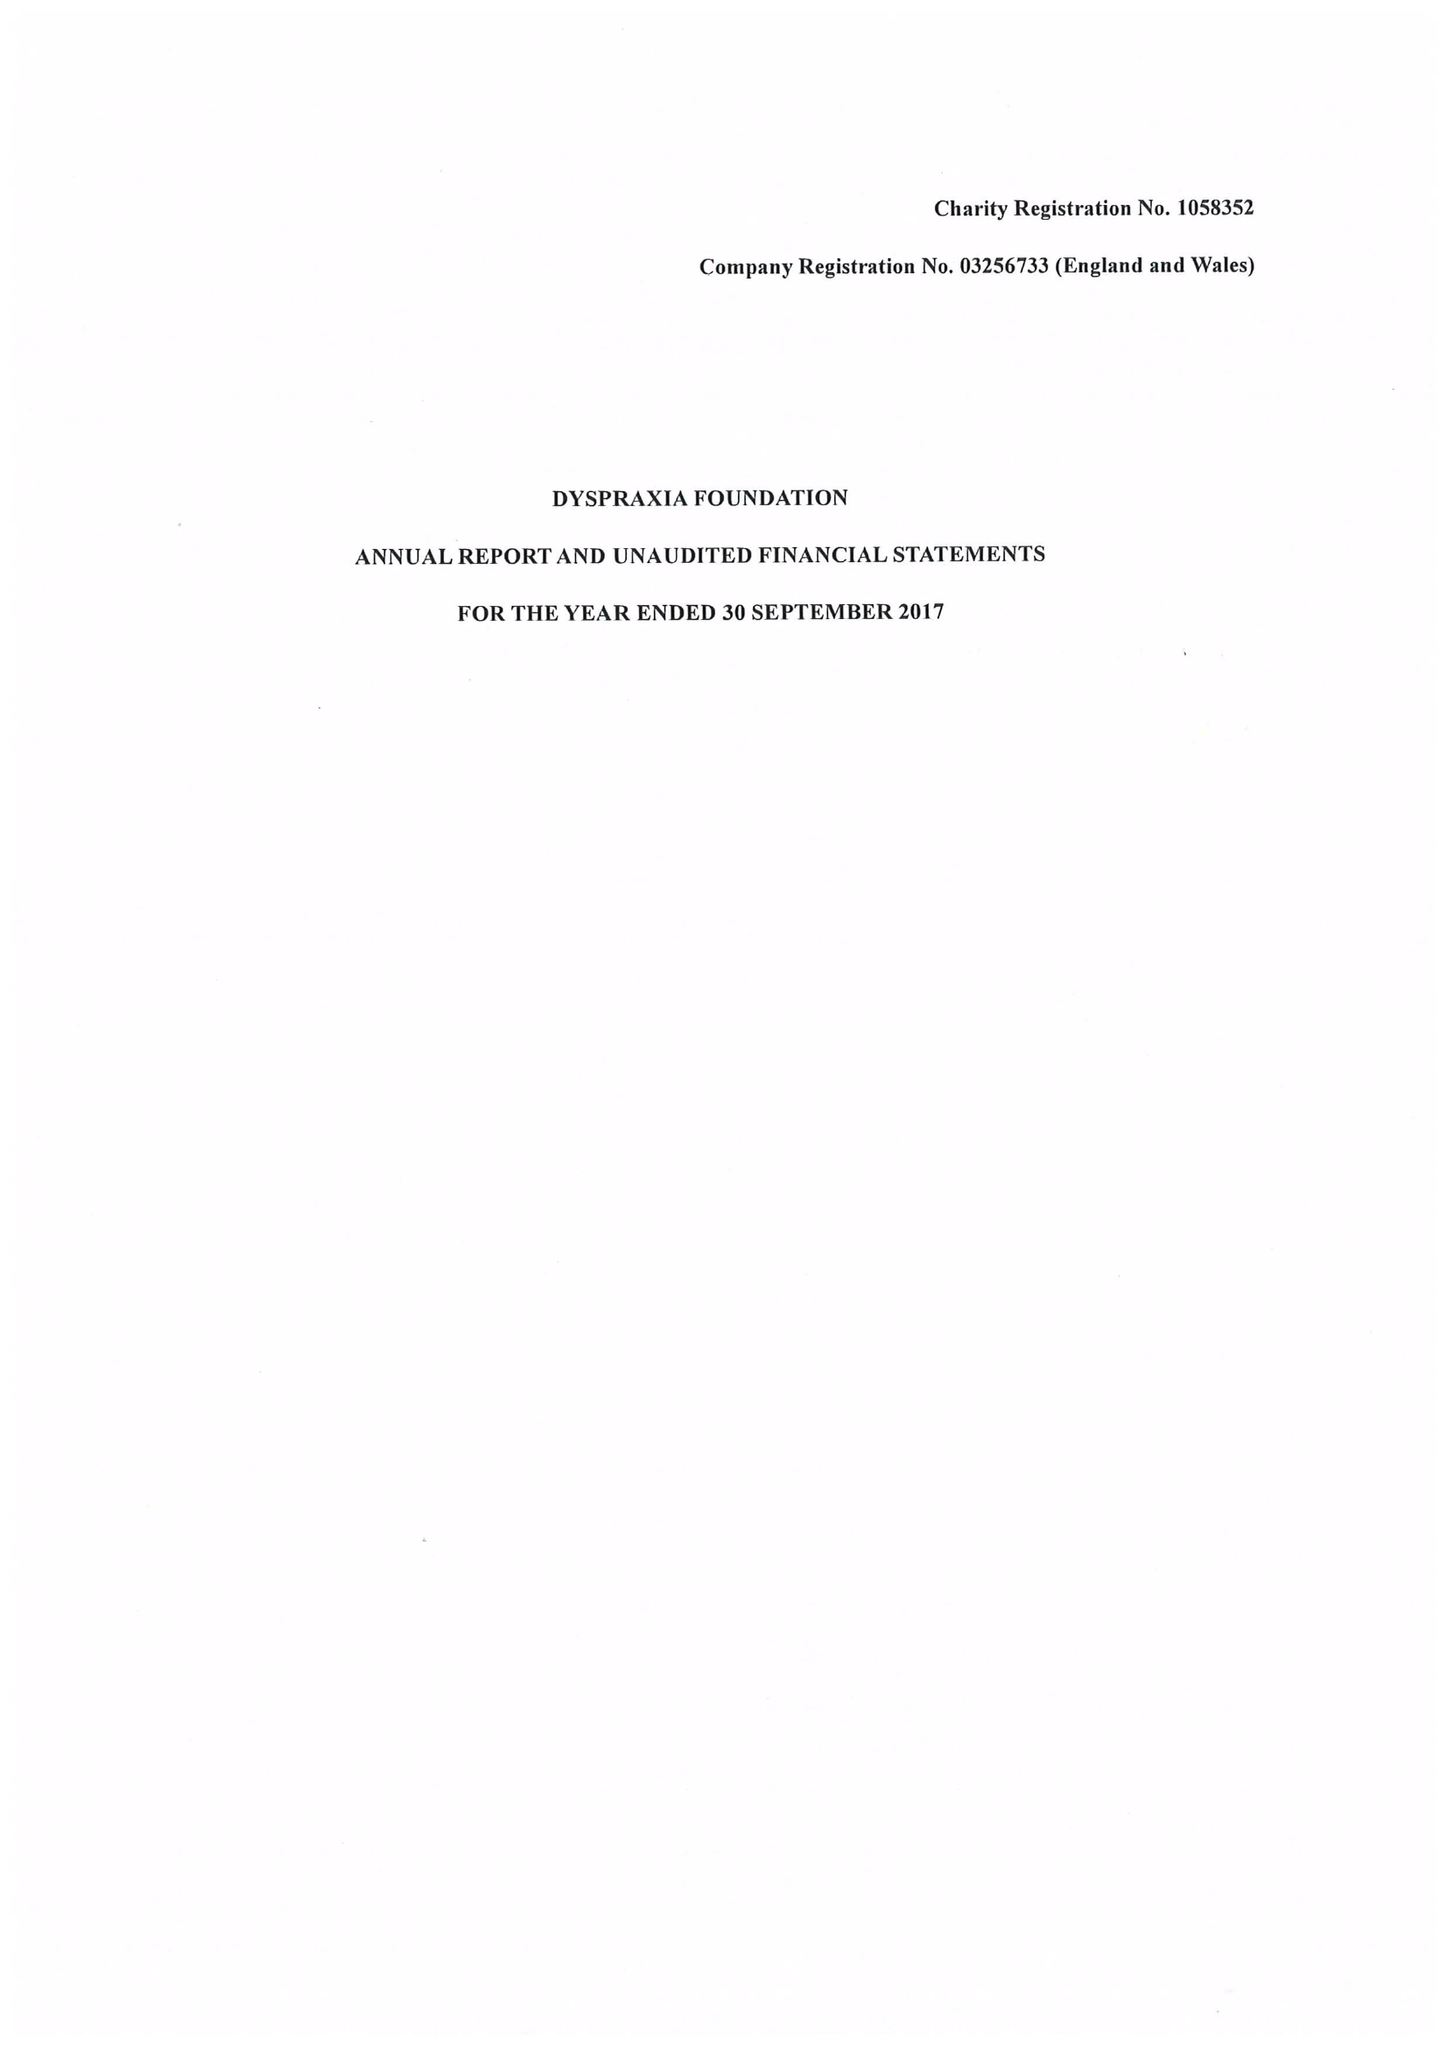What is the value for the address__post_town?
Answer the question using a single word or phrase. HITCHIN 